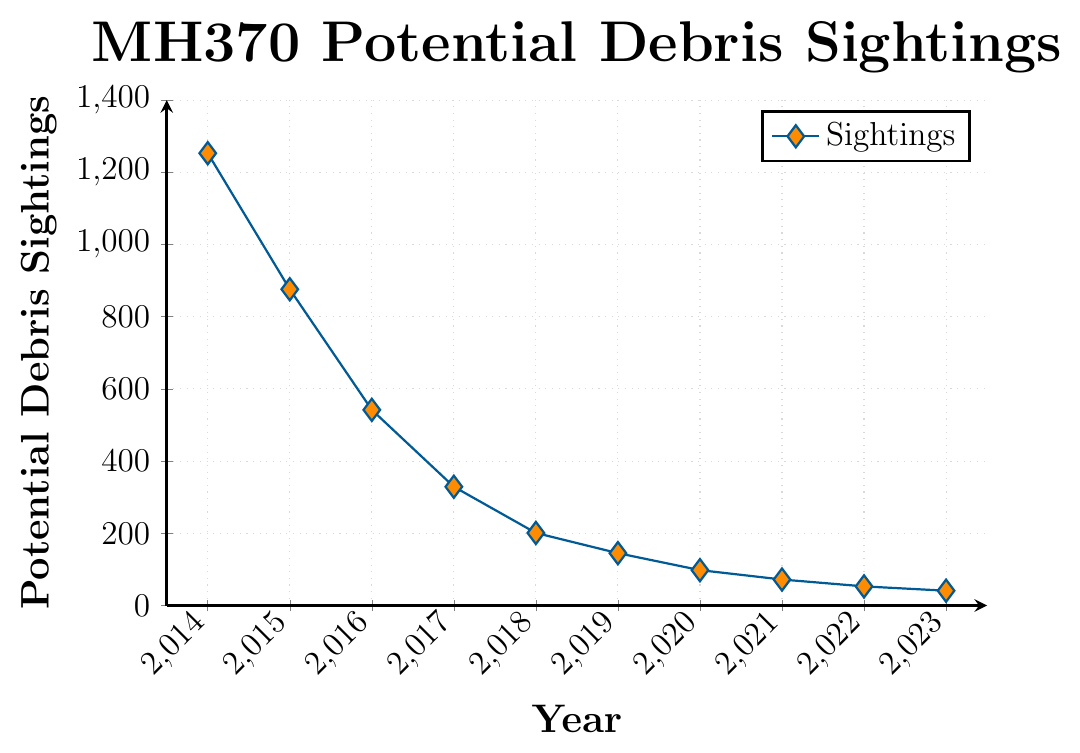What's the trend in the number of potential debris sightings from 2014 to 2023? The trend shows a steady decline in the number of potential debris sightings each year from 2014 to 2023. In 2014, there are 1253 sightings, and it continuously decreases to 41 sightings in 2023. This steady decline indicates fewer sightings being reported annually.
Answer: Steady decline In which year were the potential debris sightings the highest? The year with the highest potential debris sightings is 2014. By referring to the y-axis, we can see that the count is highest at 1253.
Answer: 2014 How many more potential debris sightings were there in 2014 compared to 2023? In 2014, there were 1253 sightings, and in 2023 there were 41. The difference between them is calculated by subtracting 41 from 1253.
Answer: 1212 What is the median number of potential debris sightings from 2014 to 2023? To find the median, we need to order the sightings from smallest to largest and find the middle value. The ordered set is: 41, 53, 72, 98, 145, 201, 329, 542, 876, 1253. The median is the average of the 5th and 6th values: (145 + 201) / 2.
Answer: 173 Compare the number of potential debris sightings in 2015 and 2016. Which year had fewer sightings? By comparing the y-values for 2015 and 2016, we find that in 2015 there are 876 sightings and in 2016 there are 542 sightings. Hence, 2016 had fewer sightings.
Answer: 2016 What's the percentage decrease in the number of potential debris sightings from 2014 to 2015? The number of sightings in 2014 is 1253, and in 2015 it is 876. The decrease is 1253 - 876 = 377. The percentage decrease is calculated as (377 / 1253) * 100%.
Answer: 30.08% What is the average number of potential debris sightings per year over the period 2014 to 2023? Adding up all the sightings from 2014 to 2023 gives a total of 3609. Dividing this by the number of years (10) gives the average: 3609 / 10.
Answer: 360.9 Which visual attributes are used to differentiate the data points on the figure? The data points are marked with a diamond shape filled with orange color, and the line connecting them is blue.
Answer: Diamond shape, orange color, blue line In which year do we observe the steepest decline in potential debris sightings? Observing the line's slope, the steepest decline occurs between 2014 and 2015, where the number of sightings drops from 1253 to 876. This decline is the largest compared to other years.
Answer: 2014 to 2015 Which year had the fewest potential debris sightings, and what was the count? The fewest potential debris sightings occurred in 2023, with a count of 41.
Answer: 2023, 41 